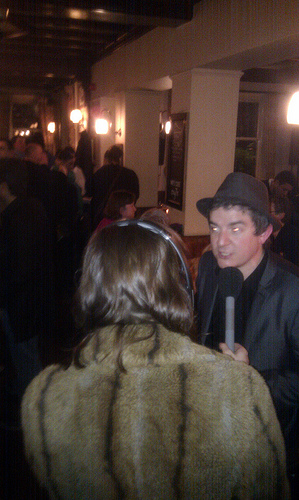<image>
Can you confirm if the girl is on the man? No. The girl is not positioned on the man. They may be near each other, but the girl is not supported by or resting on top of the man. 